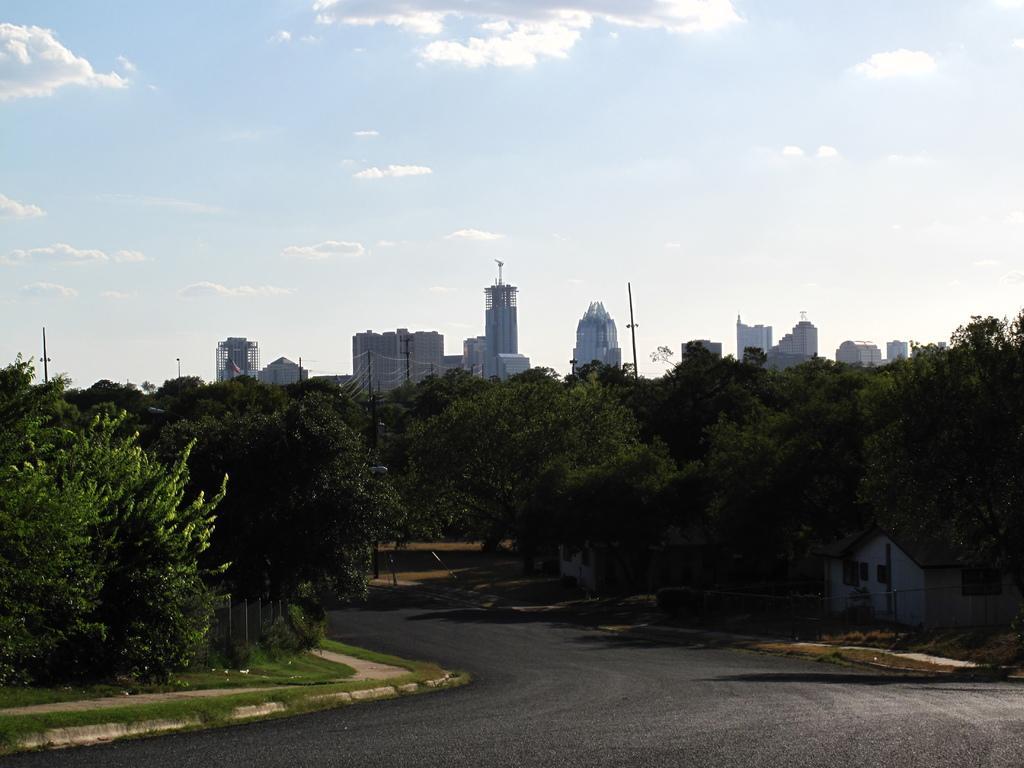Describe this image in one or two sentences. This is the picture of a place where we have a road and around there are some trees, plants and some buildings to the side. 